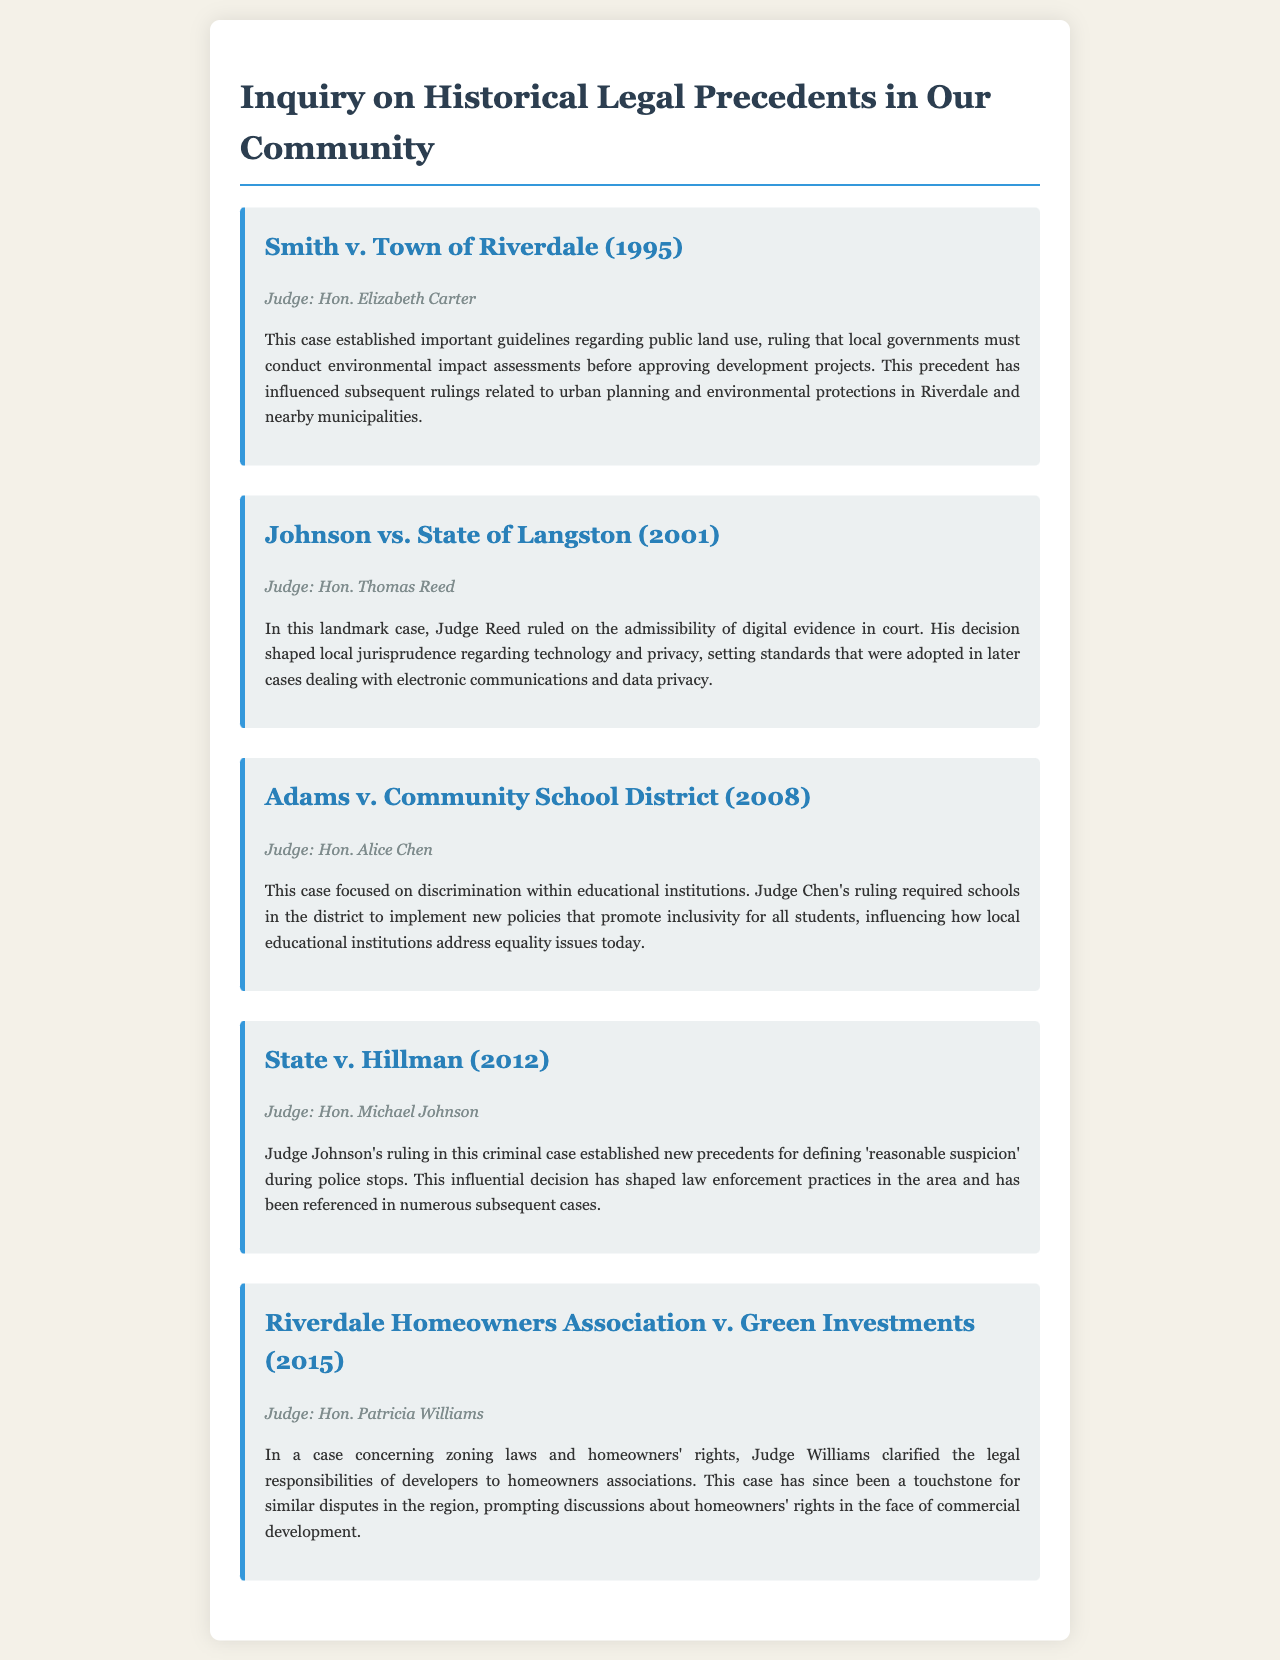What is the name of the judge in the case Smith v. Town of Riverdale? The name of the judge is explicitly mentioned in the case summary section of the document.
Answer: Hon. Elizabeth Carter What year was the case Johnson vs. State of Langston decided? This year is stated in the title of the case, indicating the momentous decision made by the court.
Answer: 2001 What legal topic did Adams v. Community School District address? The document specifies that this case focused on discrimination within educational institutions.
Answer: Discrimination Who ruled on the admissibility of digital evidence? This is specifically noted in the document detailing the case information related to Judge Reed's ruling.
Answer: Hon. Thomas Reed What was established in State v. Hillman regarding police stops? This precedent is highlighted in the case summary, outlining the key legal determination made by the judge.
Answer: Reasonable suspicion In which year did Riverdale Homeowners Association v. Green Investments take place? The year is indicated directly in the case title.
Answer: 2015 What was one significant impact of Judge Chen's ruling? The case summary details that it required schools to implement new policies for inclusivity.
Answer: Inclusivity policies How did Judge Williams’ ruling influence developers? The document mentions that her ruling clarified the legal responsibilities of developers.
Answer: Legal responsibilities What kind of case is Smith v. Town of Riverdale? The document provides a brief summary indicating the nature of the case, particularly related to public land use.
Answer: Public land use 